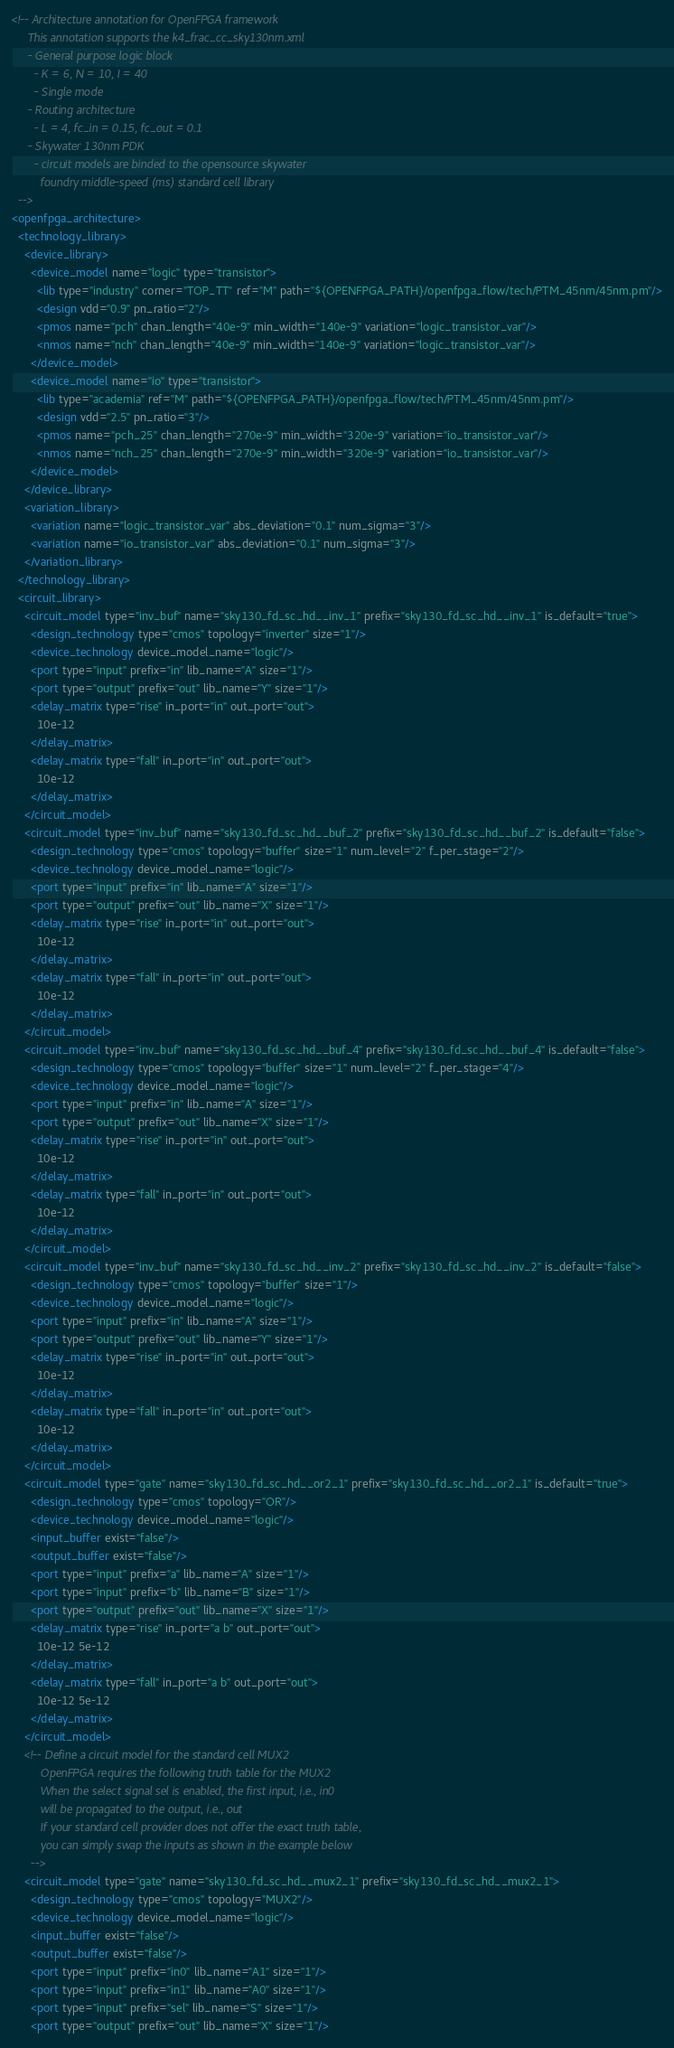<code> <loc_0><loc_0><loc_500><loc_500><_XML_><!-- Architecture annotation for OpenFPGA framework
     This annotation supports the k4_frac_cc_sky130nm.xml
     - General purpose logic block
       - K = 6, N = 10, I = 40
       - Single mode
     - Routing architecture
       - L = 4, fc_in = 0.15, fc_out = 0.1
     - Skywater 130nm PDK
       - circuit models are binded to the opensource skywater
         foundry middle-speed (ms) standard cell library
  -->
<openfpga_architecture>
  <technology_library>
    <device_library>
      <device_model name="logic" type="transistor">
        <lib type="industry" corner="TOP_TT" ref="M" path="${OPENFPGA_PATH}/openfpga_flow/tech/PTM_45nm/45nm.pm"/>
        <design vdd="0.9" pn_ratio="2"/>
        <pmos name="pch" chan_length="40e-9" min_width="140e-9" variation="logic_transistor_var"/>
        <nmos name="nch" chan_length="40e-9" min_width="140e-9" variation="logic_transistor_var"/>
      </device_model>
      <device_model name="io" type="transistor">
        <lib type="academia" ref="M" path="${OPENFPGA_PATH}/openfpga_flow/tech/PTM_45nm/45nm.pm"/>
        <design vdd="2.5" pn_ratio="3"/>
        <pmos name="pch_25" chan_length="270e-9" min_width="320e-9" variation="io_transistor_var"/>
        <nmos name="nch_25" chan_length="270e-9" min_width="320e-9" variation="io_transistor_var"/>
      </device_model>
    </device_library>
    <variation_library>
      <variation name="logic_transistor_var" abs_deviation="0.1" num_sigma="3"/>
      <variation name="io_transistor_var" abs_deviation="0.1" num_sigma="3"/>
    </variation_library>
  </technology_library>
  <circuit_library>
    <circuit_model type="inv_buf" name="sky130_fd_sc_hd__inv_1" prefix="sky130_fd_sc_hd__inv_1" is_default="true">
      <design_technology type="cmos" topology="inverter" size="1"/>
      <device_technology device_model_name="logic"/>
      <port type="input" prefix="in" lib_name="A" size="1"/>
      <port type="output" prefix="out" lib_name="Y" size="1"/>
      <delay_matrix type="rise" in_port="in" out_port="out">
        10e-12
      </delay_matrix>
      <delay_matrix type="fall" in_port="in" out_port="out">
        10e-12
      </delay_matrix>
    </circuit_model>
    <circuit_model type="inv_buf" name="sky130_fd_sc_hd__buf_2" prefix="sky130_fd_sc_hd__buf_2" is_default="false">
      <design_technology type="cmos" topology="buffer" size="1" num_level="2" f_per_stage="2"/>
      <device_technology device_model_name="logic"/>
      <port type="input" prefix="in" lib_name="A" size="1"/>
      <port type="output" prefix="out" lib_name="X" size="1"/>
      <delay_matrix type="rise" in_port="in" out_port="out">
        10e-12
      </delay_matrix>
      <delay_matrix type="fall" in_port="in" out_port="out">
        10e-12
      </delay_matrix>
    </circuit_model>
    <circuit_model type="inv_buf" name="sky130_fd_sc_hd__buf_4" prefix="sky130_fd_sc_hd__buf_4" is_default="false">
      <design_technology type="cmos" topology="buffer" size="1" num_level="2" f_per_stage="4"/>
      <device_technology device_model_name="logic"/>
      <port type="input" prefix="in" lib_name="A" size="1"/>
      <port type="output" prefix="out" lib_name="X" size="1"/>
      <delay_matrix type="rise" in_port="in" out_port="out">
        10e-12
      </delay_matrix>
      <delay_matrix type="fall" in_port="in" out_port="out">
        10e-12
      </delay_matrix>
    </circuit_model>
    <circuit_model type="inv_buf" name="sky130_fd_sc_hd__inv_2" prefix="sky130_fd_sc_hd__inv_2" is_default="false">
      <design_technology type="cmos" topology="buffer" size="1"/>
      <device_technology device_model_name="logic"/>
      <port type="input" prefix="in" lib_name="A" size="1"/>
      <port type="output" prefix="out" lib_name="Y" size="1"/>
      <delay_matrix type="rise" in_port="in" out_port="out">
        10e-12
      </delay_matrix>
      <delay_matrix type="fall" in_port="in" out_port="out">
        10e-12
      </delay_matrix>
    </circuit_model>
    <circuit_model type="gate" name="sky130_fd_sc_hd__or2_1" prefix="sky130_fd_sc_hd__or2_1" is_default="true">
      <design_technology type="cmos" topology="OR"/>
      <device_technology device_model_name="logic"/>
      <input_buffer exist="false"/>
      <output_buffer exist="false"/>
      <port type="input" prefix="a" lib_name="A" size="1"/>
      <port type="input" prefix="b" lib_name="B" size="1"/>
      <port type="output" prefix="out" lib_name="X" size="1"/>
      <delay_matrix type="rise" in_port="a b" out_port="out">
        10e-12 5e-12
      </delay_matrix>
      <delay_matrix type="fall" in_port="a b" out_port="out">
        10e-12 5e-12
      </delay_matrix>
    </circuit_model>
    <!-- Define a circuit model for the standard cell MUX2
         OpenFPGA requires the following truth table for the MUX2
         When the select signal sel is enabled, the first input, i.e., in0
         will be propagated to the output, i.e., out
         If your standard cell provider does not offer the exact truth table,
         you can simply swap the inputs as shown in the example below
      -->
    <circuit_model type="gate" name="sky130_fd_sc_hd__mux2_1" prefix="sky130_fd_sc_hd__mux2_1">
      <design_technology type="cmos" topology="MUX2"/>
      <device_technology device_model_name="logic"/>
      <input_buffer exist="false"/>
      <output_buffer exist="false"/>
      <port type="input" prefix="in0" lib_name="A1" size="1"/>
      <port type="input" prefix="in1" lib_name="A0" size="1"/>
      <port type="input" prefix="sel" lib_name="S" size="1"/>
      <port type="output" prefix="out" lib_name="X" size="1"/></code> 